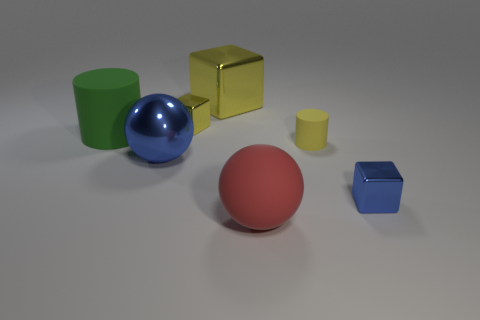There is a large block; is its color the same as the tiny shiny block that is on the left side of the small yellow cylinder?
Offer a very short reply. Yes. There is a cylinder that is the same color as the large metal block; what material is it?
Ensure brevity in your answer.  Rubber. What shape is the blue thing that is on the left side of the matte cylinder on the right side of the large metal thing that is behind the tiny yellow block?
Keep it short and to the point. Sphere. What is the shape of the green rubber thing?
Your answer should be compact. Cylinder. There is a cube on the left side of the large yellow cube; what is its color?
Give a very brief answer. Yellow. Is the size of the blue thing that is behind the blue metal block the same as the large cube?
Give a very brief answer. Yes. What size is the blue thing that is the same shape as the tiny yellow metallic thing?
Your response must be concise. Small. Does the red object have the same shape as the big blue object?
Offer a terse response. Yes. Are there fewer tiny objects that are in front of the blue shiny block than cylinders left of the blue metallic ball?
Keep it short and to the point. Yes. There is a red object; what number of rubber spheres are in front of it?
Your answer should be compact. 0. 